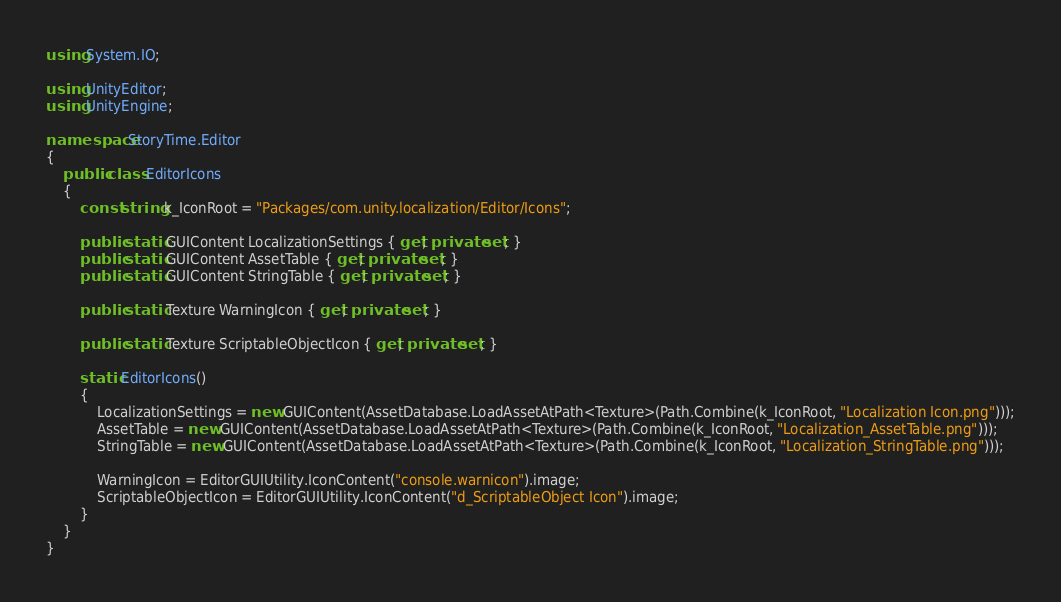<code> <loc_0><loc_0><loc_500><loc_500><_C#_>using System.IO;

using UnityEditor;
using UnityEngine;

namespace StoryTime.Editor
{
    public class EditorIcons
    {
        const string k_IconRoot = "Packages/com.unity.localization/Editor/Icons";

        public static GUIContent LocalizationSettings { get; private set; }
        public static GUIContent AssetTable { get; private set; }
        public static GUIContent StringTable { get; private set; }

        public static Texture WarningIcon { get; private set; }

        public static Texture ScriptableObjectIcon { get; private set; }

        static EditorIcons()
        {
            LocalizationSettings = new GUIContent(AssetDatabase.LoadAssetAtPath<Texture>(Path.Combine(k_IconRoot, "Localization Icon.png")));
            AssetTable = new GUIContent(AssetDatabase.LoadAssetAtPath<Texture>(Path.Combine(k_IconRoot, "Localization_AssetTable.png")));
            StringTable = new GUIContent(AssetDatabase.LoadAssetAtPath<Texture>(Path.Combine(k_IconRoot, "Localization_StringTable.png")));

            WarningIcon = EditorGUIUtility.IconContent("console.warnicon").image;
            ScriptableObjectIcon = EditorGUIUtility.IconContent("d_ScriptableObject Icon").image;
        }
    }
}
</code> 